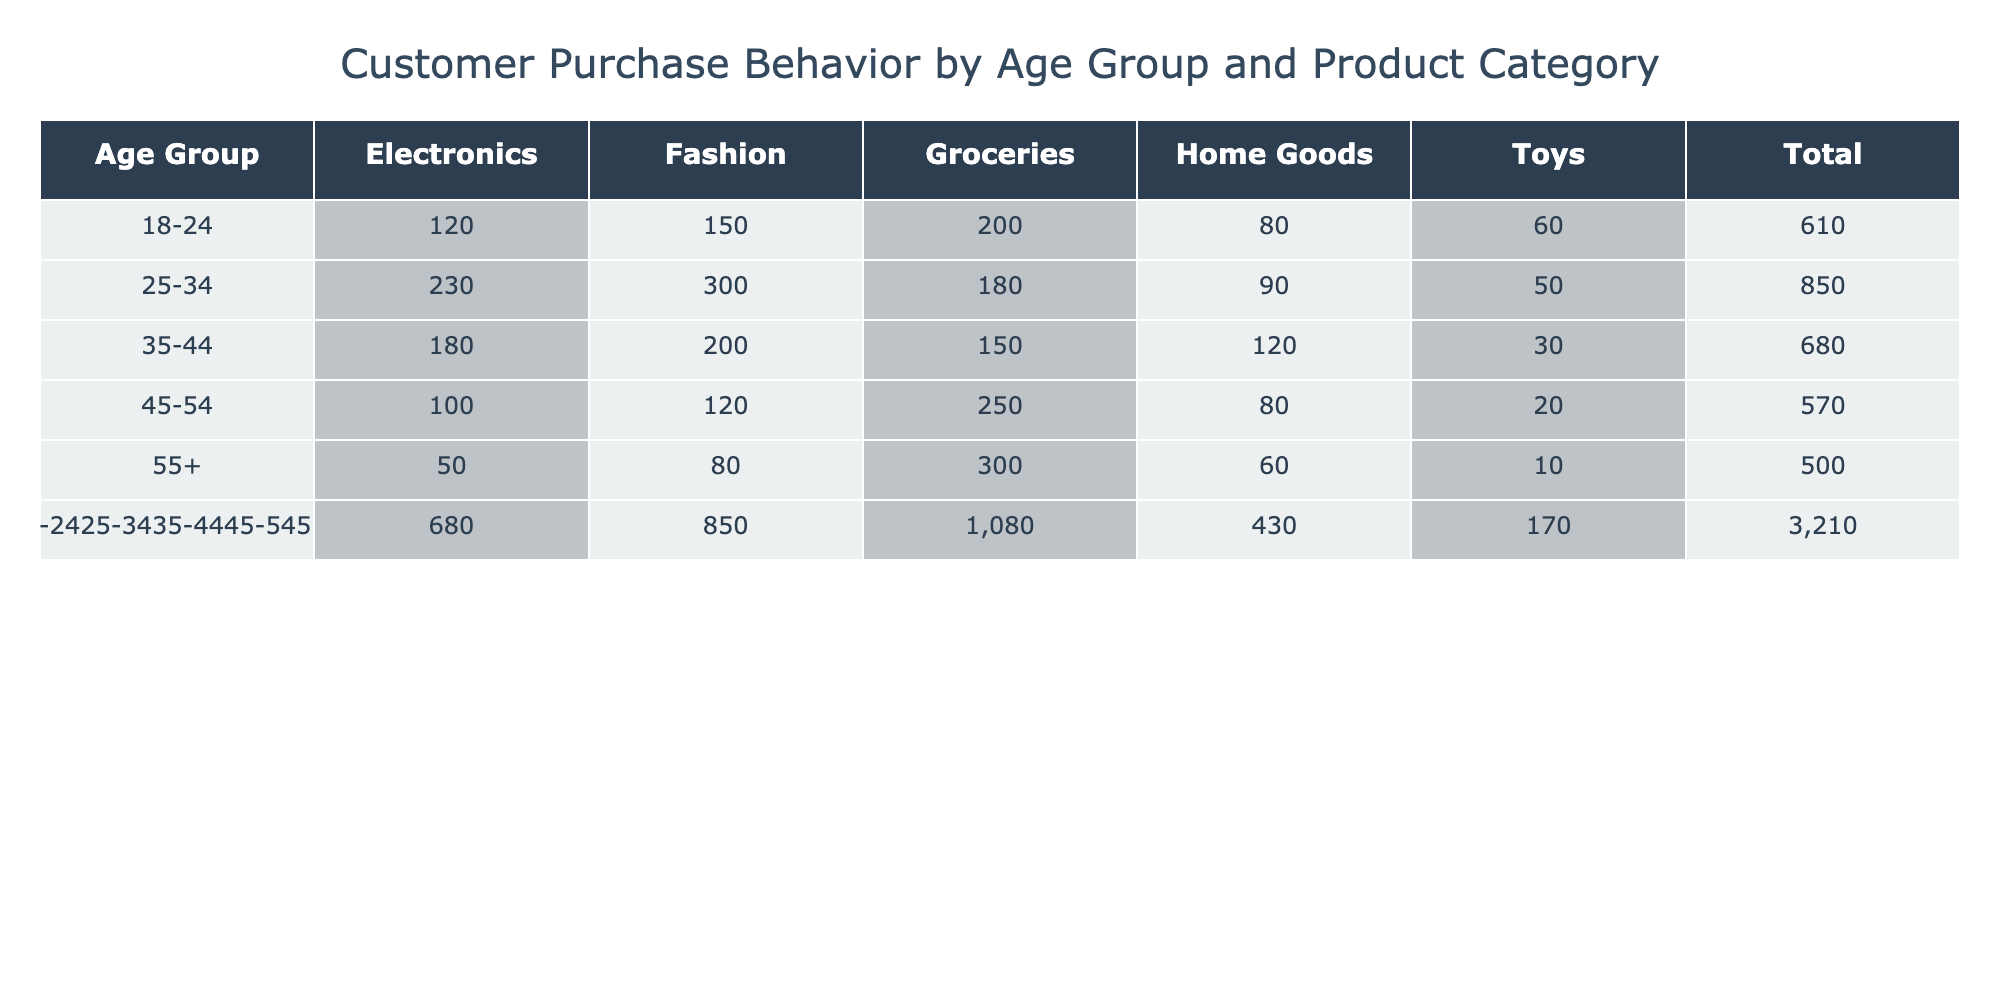What age group has the highest total purchases? To find the age group with the highest total purchases, we can look at the 'Total' column. The total for each age group is as follows: 18-24 (610), 25-34 (850), 35-44 (680), 45-54 (570), and 55+ (500). The highest total is 850 for the age group 25-34.
Answer: 25-34 How many purchases did the 45-54 age group make in the Fashion category? We simply look at the Fashion column for the 45-54 age group, which shows a value of 120.
Answer: 120 What is the total number of purchases made by customers aged 18-24 in the Toy category? Referring to the Toy column under the 18-24 age group, we see 60.
Answer: 60 Is the total number of purchases for the 55+ age group greater than the total for the 45-54 age group? The total for the 55+ age group is 500, while for the 45-54 age group it is 570. Since 500 is less than 570, the statement is false.
Answer: No What is the average number of purchases in the Groceries category across all age groups? We add the numbers from the Groceries column for all age groups: (200 + 180 + 150 + 250 + 300) = 1080. There are 5 age groups, so the average is 1080 divided by 5, which equals 216.
Answer: 216 Which product category has the least purchases overall? We need to calculate the total for each product category by summing each column. For Electronics, the total is 120 + 230 + 180 + 100 + 50 = 680; for Fashion, it is 150 + 300 + 200 + 120 + 80 = 850; for Groceries, it is 200 + 180 + 150 + 250 + 300 = 1080; for Home Goods, it is 80 + 90 + 120 + 80 + 60 = 430; and for Toys, it is 60 + 50 + 30 + 20 + 10 = 170. The category with the least purchases is Toys with a total of 170.
Answer: Toys What is the difference in total purchases between the age groups 35-44 and 55+? From the Total column, the 35-44 age group has a total of 680 and the 55+ age group has a total of 500. The difference is 680 - 500 = 180.
Answer: 180 Did the 18-24 age group spend more on Fashion than on Electronics? For the 18-24 age group, the Fashion category shows 150 purchases and Electronics shows 120. Since 150 is greater than 120, the statement is true.
Answer: Yes Which age group made the highest purchases in Groceries? Looking at the Groceries column, the 45-54 age group shows 250 purchases, which is the highest compared to other age groups: 200 for 18-24, 180 for 25-34, 150 for 35-44, and 300 for 55+. So, the 45-54 age group has the highest purchases in Groceries.
Answer: 45-54 